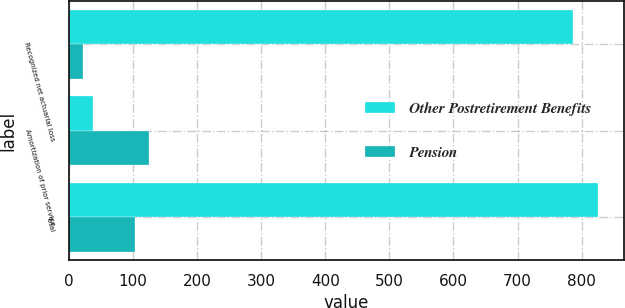Convert chart to OTSL. <chart><loc_0><loc_0><loc_500><loc_500><stacked_bar_chart><ecel><fcel>Recognized net actuarial loss<fcel>Amortization of prior service<fcel>Total<nl><fcel>Other Postretirement Benefits<fcel>787<fcel>38<fcel>825<nl><fcel>Pension<fcel>22<fcel>126<fcel>104<nl></chart> 